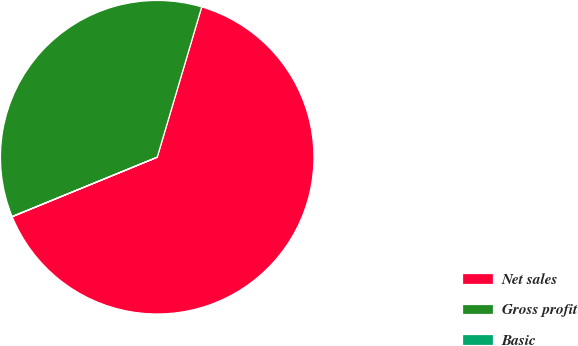Convert chart. <chart><loc_0><loc_0><loc_500><loc_500><pie_chart><fcel>Net sales<fcel>Gross profit<fcel>Basic<nl><fcel>64.22%<fcel>35.76%<fcel>0.02%<nl></chart> 